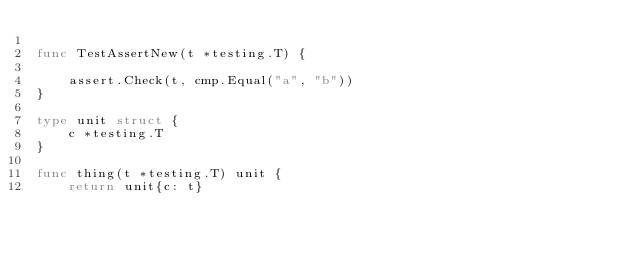Convert code to text. <code><loc_0><loc_0><loc_500><loc_500><_Go_>
func TestAssertNew(t *testing.T) {

	assert.Check(t, cmp.Equal("a", "b"))
}

type unit struct {
	c *testing.T
}

func thing(t *testing.T) unit {
	return unit{c: t}</code> 